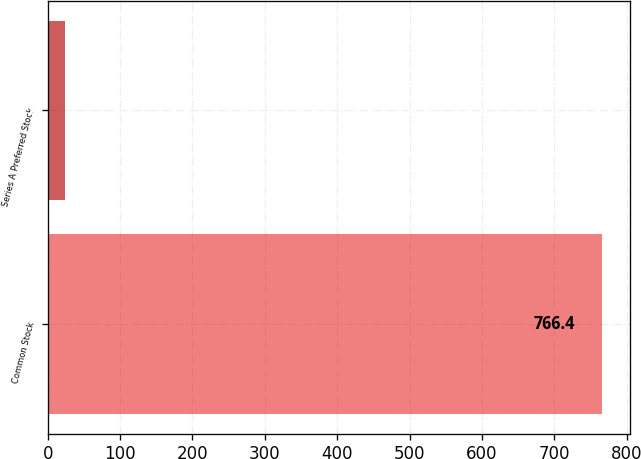Convert chart to OTSL. <chart><loc_0><loc_0><loc_500><loc_500><bar_chart><fcel>Common Stock<fcel>Series A Preferred Stock<nl><fcel>766.4<fcel>23.7<nl></chart> 